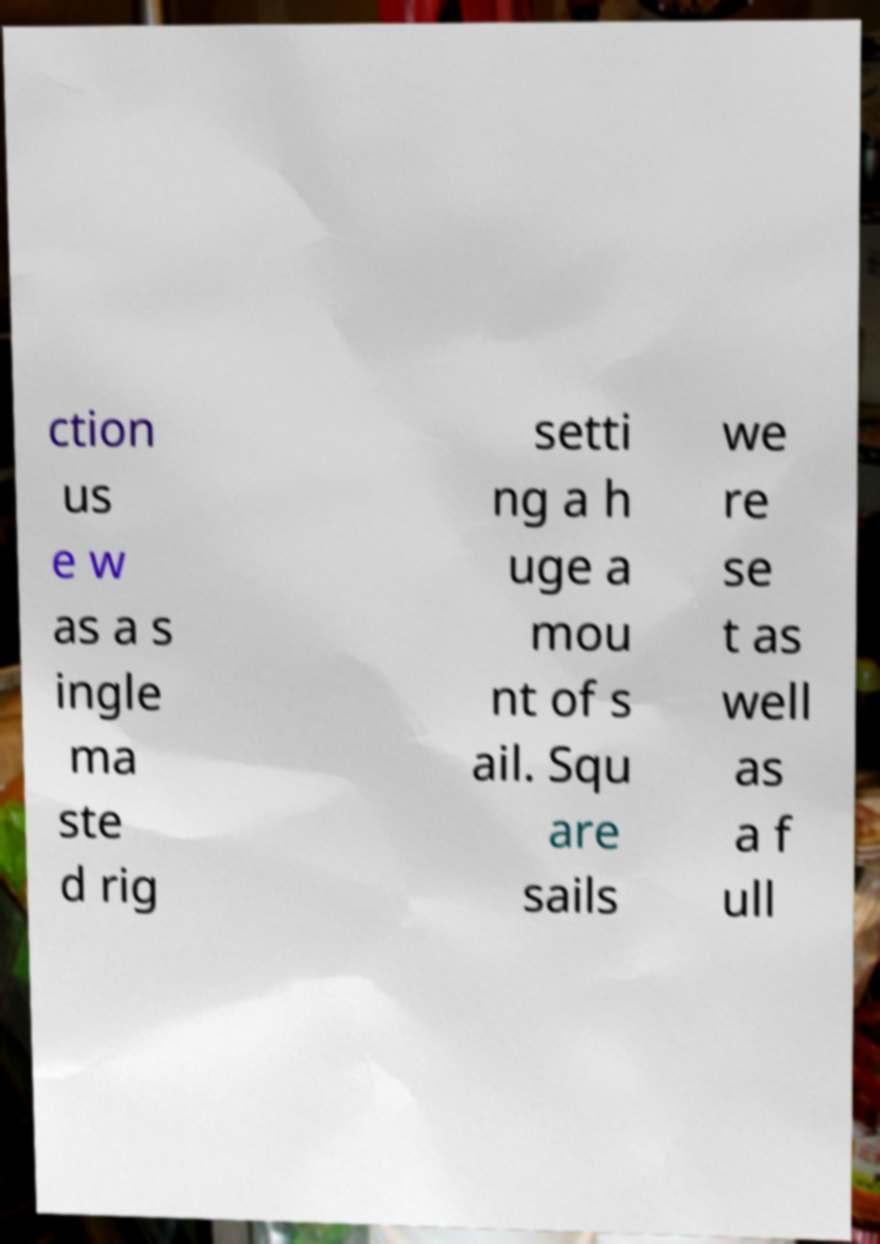Please identify and transcribe the text found in this image. ction us e w as a s ingle ma ste d rig setti ng a h uge a mou nt of s ail. Squ are sails we re se t as well as a f ull 